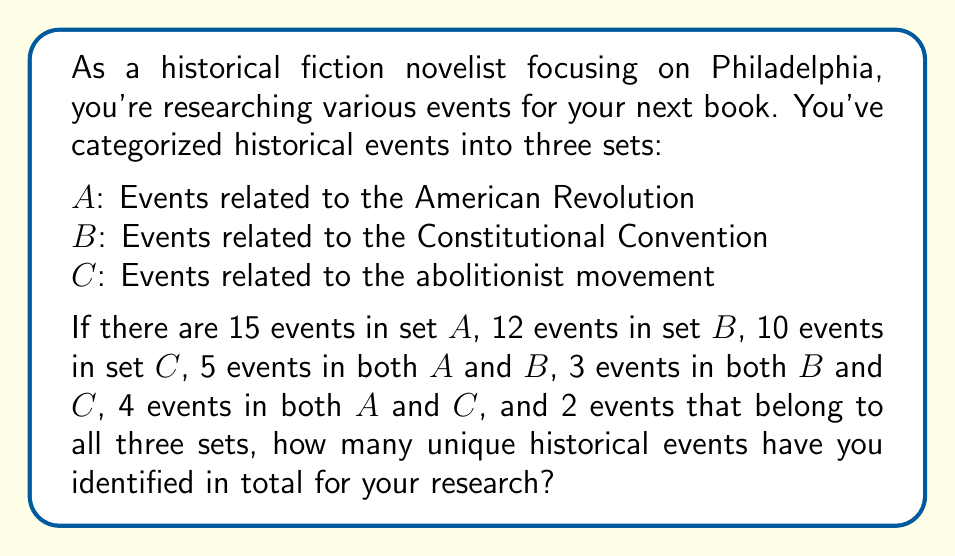What is the answer to this math problem? To solve this problem, we'll use the principle of inclusion-exclusion from set theory. Let's break it down step-by-step:

1. First, let's define the universe $U$ as all the unique historical events.

2. We're given:
   $|A| = 15$, $|B| = 12$, $|C| = 10$
   $|A \cap B| = 5$, $|B \cap C| = 3$, $|A \cap C| = 4$
   $|A \cap B \cap C| = 2$

3. The principle of inclusion-exclusion for three sets states:

   $|A \cup B \cup C| = |A| + |B| + |C| - |A \cap B| - |B \cap C| - |A \cap C| + |A \cap B \cap C|$

4. Let's substitute our values:

   $|U| = 15 + 12 + 10 - 5 - 3 - 4 + 2$

5. Now, let's calculate:

   $|U| = 37 - 12 + 2 = 27$

Therefore, you have identified 27 unique historical events for your research.
Answer: 27 unique historical events 